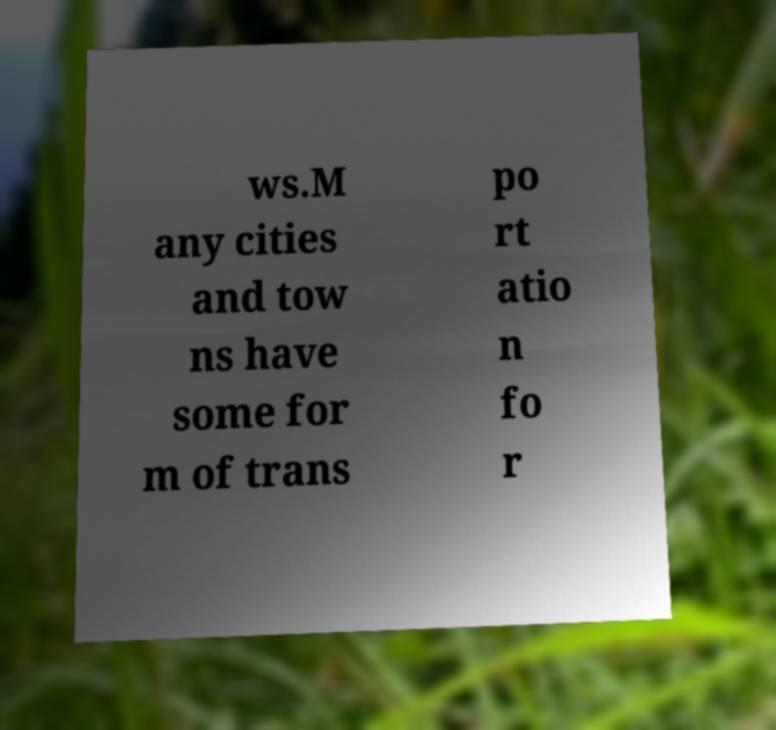Could you extract and type out the text from this image? ws.M any cities and tow ns have some for m of trans po rt atio n fo r 